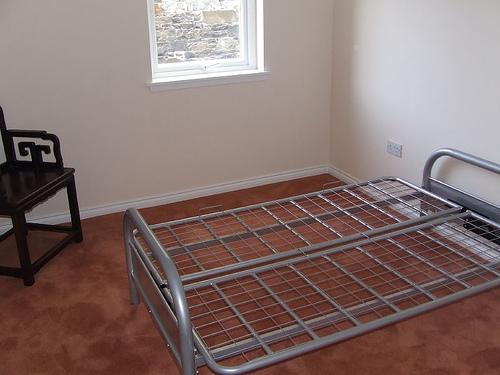What color is the bedding?
Concise answer only. No bedding. Is this a futon frame?
Be succinct. Yes. What color is the carpet?
Keep it brief. Brown. 